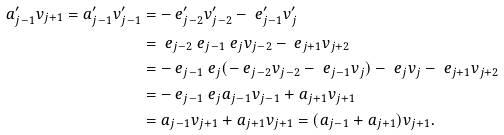Convert formula to latex. <formula><loc_0><loc_0><loc_500><loc_500>a _ { j - 1 } ^ { \prime } v _ { j + 1 } = a _ { j - 1 } ^ { \prime } v _ { j - 1 } ^ { \prime } & = - \ e _ { j - 2 } ^ { \prime } v _ { j - 2 } ^ { \prime } - \ e _ { j - 1 } ^ { \prime } v _ { j } ^ { \prime } \\ & = \ e _ { j - 2 } \ e _ { j - 1 } \ e _ { j } v _ { j - 2 } - \ e _ { j + 1 } v _ { j + 2 } \\ & = - \ e _ { j - 1 } \ e _ { j } ( - \ e _ { j - 2 } v _ { j - 2 } - \ e _ { j - 1 } v _ { j } ) - \ e _ { j } v _ { j } - \ e _ { j + 1 } v _ { j + 2 } \\ & = - \ e _ { j - 1 } \ e _ { j } a _ { j - 1 } v _ { j - 1 } + a _ { j + 1 } v _ { j + 1 } \\ & = a _ { j - 1 } v _ { j + 1 } + a _ { j + 1 } v _ { j + 1 } = ( a _ { j - 1 } + a _ { j + 1 } ) v _ { j + 1 } .</formula> 